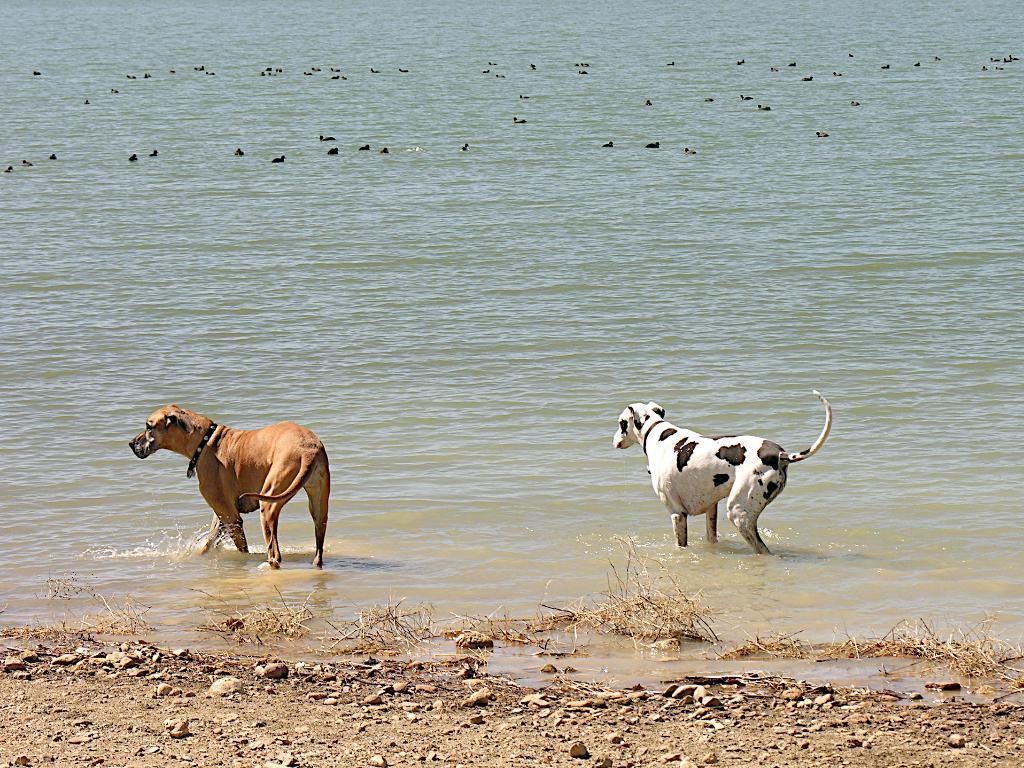Describe this image in one or two sentences. In the picture I can see a dalmatian dog and a dog which is in gold color are walking in the water. Here I can see the stones and a few more animals swimming in the water. 